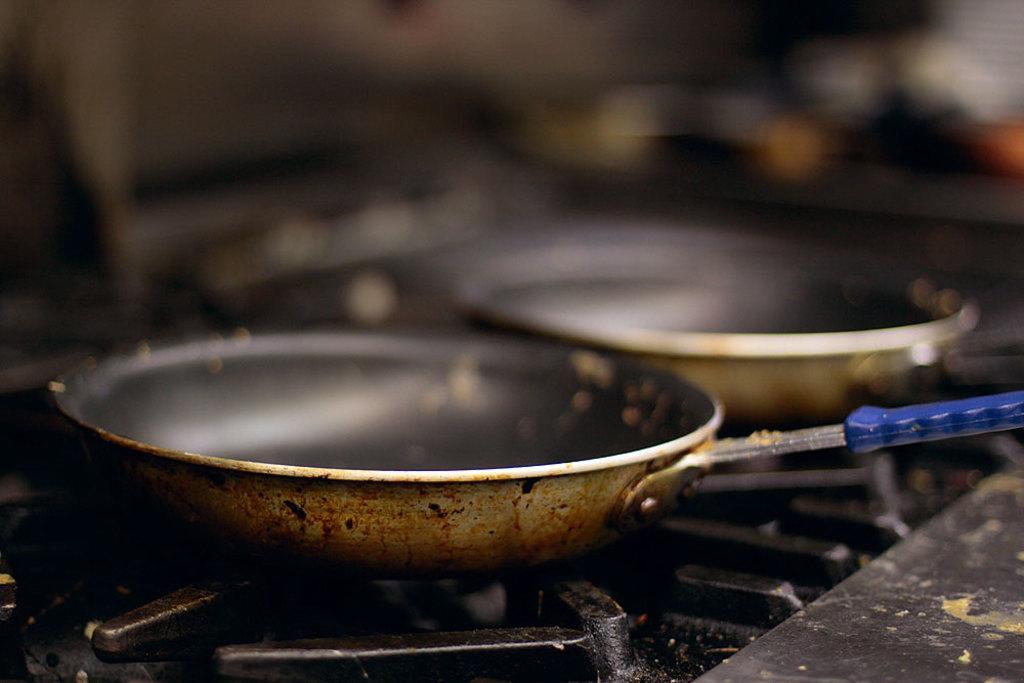Can you describe this image briefly? In this image we can see two pans on a stove. 